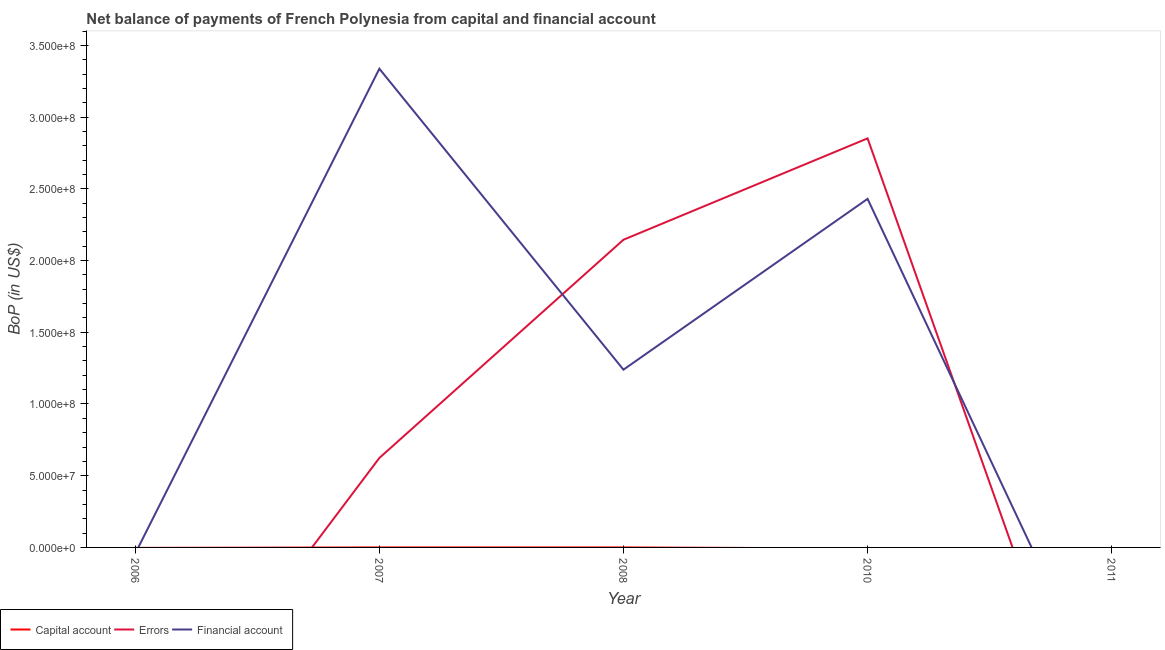How many different coloured lines are there?
Keep it short and to the point. 3. What is the amount of errors in 2011?
Provide a short and direct response. 0. Across all years, what is the maximum amount of financial account?
Provide a short and direct response. 3.34e+08. Across all years, what is the minimum amount of financial account?
Provide a succinct answer. 0. In which year was the amount of errors maximum?
Your answer should be very brief. 2010. What is the total amount of net capital account in the graph?
Offer a very short reply. 8350.98. What is the difference between the amount of financial account in 2007 and that in 2008?
Provide a short and direct response. 2.10e+08. What is the difference between the amount of net capital account in 2007 and the amount of errors in 2006?
Ensure brevity in your answer.  0. What is the average amount of financial account per year?
Your answer should be compact. 1.40e+08. In the year 2008, what is the difference between the amount of net capital account and amount of errors?
Provide a short and direct response. -2.15e+08. What is the difference between the highest and the second highest amount of financial account?
Provide a short and direct response. 9.07e+07. What is the difference between the highest and the lowest amount of financial account?
Keep it short and to the point. 3.34e+08. Does the amount of errors monotonically increase over the years?
Offer a very short reply. No. Is the amount of financial account strictly greater than the amount of net capital account over the years?
Provide a short and direct response. No. How many lines are there?
Keep it short and to the point. 3. What is the difference between two consecutive major ticks on the Y-axis?
Keep it short and to the point. 5.00e+07. Does the graph contain grids?
Provide a succinct answer. No. Where does the legend appear in the graph?
Provide a succinct answer. Bottom left. How are the legend labels stacked?
Offer a very short reply. Horizontal. What is the title of the graph?
Your answer should be compact. Net balance of payments of French Polynesia from capital and financial account. Does "Social Protection and Labor" appear as one of the legend labels in the graph?
Offer a very short reply. No. What is the label or title of the Y-axis?
Provide a short and direct response. BoP (in US$). What is the BoP (in US$) of Errors in 2007?
Ensure brevity in your answer.  6.24e+07. What is the BoP (in US$) in Financial account in 2007?
Your answer should be compact. 3.34e+08. What is the BoP (in US$) in Capital account in 2008?
Give a very brief answer. 8350.98. What is the BoP (in US$) in Errors in 2008?
Offer a terse response. 2.15e+08. What is the BoP (in US$) in Financial account in 2008?
Offer a very short reply. 1.24e+08. What is the BoP (in US$) of Errors in 2010?
Your answer should be very brief. 2.85e+08. What is the BoP (in US$) of Financial account in 2010?
Make the answer very short. 2.43e+08. What is the BoP (in US$) in Capital account in 2011?
Give a very brief answer. 0. What is the BoP (in US$) in Errors in 2011?
Provide a succinct answer. 0. What is the BoP (in US$) in Financial account in 2011?
Make the answer very short. 0. Across all years, what is the maximum BoP (in US$) in Capital account?
Make the answer very short. 8350.98. Across all years, what is the maximum BoP (in US$) of Errors?
Offer a very short reply. 2.85e+08. Across all years, what is the maximum BoP (in US$) of Financial account?
Your answer should be compact. 3.34e+08. Across all years, what is the minimum BoP (in US$) of Financial account?
Provide a short and direct response. 0. What is the total BoP (in US$) of Capital account in the graph?
Make the answer very short. 8350.98. What is the total BoP (in US$) of Errors in the graph?
Your answer should be compact. 5.62e+08. What is the total BoP (in US$) of Financial account in the graph?
Provide a short and direct response. 7.01e+08. What is the difference between the BoP (in US$) in Errors in 2007 and that in 2008?
Provide a succinct answer. -1.52e+08. What is the difference between the BoP (in US$) in Financial account in 2007 and that in 2008?
Your response must be concise. 2.10e+08. What is the difference between the BoP (in US$) of Errors in 2007 and that in 2010?
Ensure brevity in your answer.  -2.23e+08. What is the difference between the BoP (in US$) of Financial account in 2007 and that in 2010?
Ensure brevity in your answer.  9.07e+07. What is the difference between the BoP (in US$) in Errors in 2008 and that in 2010?
Offer a terse response. -7.07e+07. What is the difference between the BoP (in US$) of Financial account in 2008 and that in 2010?
Ensure brevity in your answer.  -1.19e+08. What is the difference between the BoP (in US$) in Errors in 2007 and the BoP (in US$) in Financial account in 2008?
Offer a very short reply. -6.16e+07. What is the difference between the BoP (in US$) of Errors in 2007 and the BoP (in US$) of Financial account in 2010?
Your answer should be compact. -1.81e+08. What is the difference between the BoP (in US$) of Capital account in 2008 and the BoP (in US$) of Errors in 2010?
Ensure brevity in your answer.  -2.85e+08. What is the difference between the BoP (in US$) of Capital account in 2008 and the BoP (in US$) of Financial account in 2010?
Keep it short and to the point. -2.43e+08. What is the difference between the BoP (in US$) of Errors in 2008 and the BoP (in US$) of Financial account in 2010?
Provide a short and direct response. -2.85e+07. What is the average BoP (in US$) of Capital account per year?
Provide a succinct answer. 1670.2. What is the average BoP (in US$) of Errors per year?
Provide a short and direct response. 1.12e+08. What is the average BoP (in US$) of Financial account per year?
Offer a terse response. 1.40e+08. In the year 2007, what is the difference between the BoP (in US$) of Errors and BoP (in US$) of Financial account?
Give a very brief answer. -2.71e+08. In the year 2008, what is the difference between the BoP (in US$) of Capital account and BoP (in US$) of Errors?
Give a very brief answer. -2.15e+08. In the year 2008, what is the difference between the BoP (in US$) of Capital account and BoP (in US$) of Financial account?
Make the answer very short. -1.24e+08. In the year 2008, what is the difference between the BoP (in US$) in Errors and BoP (in US$) in Financial account?
Give a very brief answer. 9.06e+07. In the year 2010, what is the difference between the BoP (in US$) in Errors and BoP (in US$) in Financial account?
Provide a short and direct response. 4.22e+07. What is the ratio of the BoP (in US$) of Errors in 2007 to that in 2008?
Provide a succinct answer. 0.29. What is the ratio of the BoP (in US$) of Financial account in 2007 to that in 2008?
Your response must be concise. 2.69. What is the ratio of the BoP (in US$) in Errors in 2007 to that in 2010?
Offer a very short reply. 0.22. What is the ratio of the BoP (in US$) in Financial account in 2007 to that in 2010?
Your answer should be very brief. 1.37. What is the ratio of the BoP (in US$) in Errors in 2008 to that in 2010?
Offer a terse response. 0.75. What is the ratio of the BoP (in US$) of Financial account in 2008 to that in 2010?
Make the answer very short. 0.51. What is the difference between the highest and the second highest BoP (in US$) in Errors?
Offer a terse response. 7.07e+07. What is the difference between the highest and the second highest BoP (in US$) of Financial account?
Your answer should be very brief. 9.07e+07. What is the difference between the highest and the lowest BoP (in US$) of Capital account?
Offer a very short reply. 8350.98. What is the difference between the highest and the lowest BoP (in US$) in Errors?
Ensure brevity in your answer.  2.85e+08. What is the difference between the highest and the lowest BoP (in US$) in Financial account?
Your answer should be very brief. 3.34e+08. 